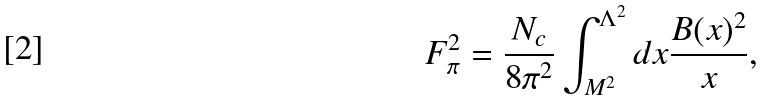Convert formula to latex. <formula><loc_0><loc_0><loc_500><loc_500>F _ { \pi } ^ { 2 } = \frac { N _ { c } } { 8 \pi ^ { 2 } } \int _ { M ^ { 2 } } ^ { \Lambda ^ { 2 } } d x \frac { B ( x ) ^ { 2 } } { x } ,</formula> 